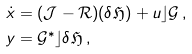<formula> <loc_0><loc_0><loc_500><loc_500>\dot { x } & = ( \mathcal { J } - \mathcal { R } ) ( \delta \mathfrak { H } ) + u \rfloor \mathcal { G } \, , \\ y & = \mathcal { G } ^ { * } \rfloor \delta \mathfrak { H } \, ,</formula> 